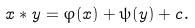<formula> <loc_0><loc_0><loc_500><loc_500>x * y = \varphi ( x ) + \psi ( y ) + c .</formula> 